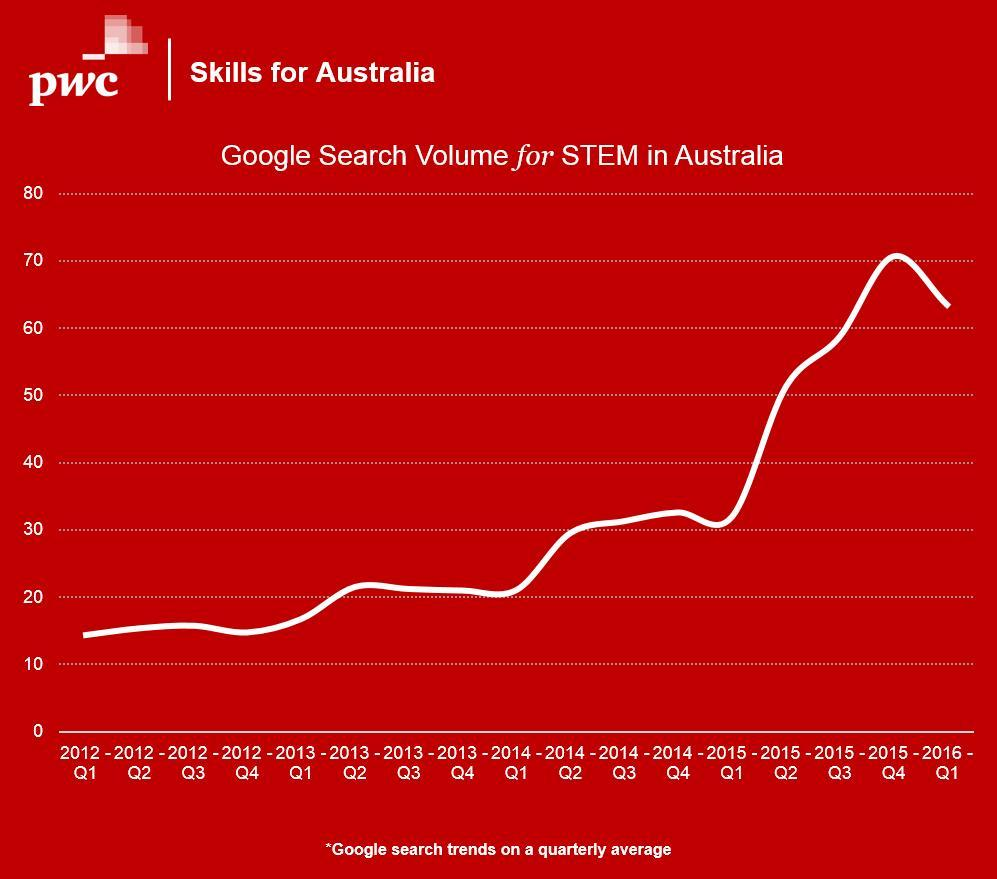Compared to 2015 Q4, volume for 2016 Q1 goes - higher or lower?
Answer the question with a short phrase. lower 